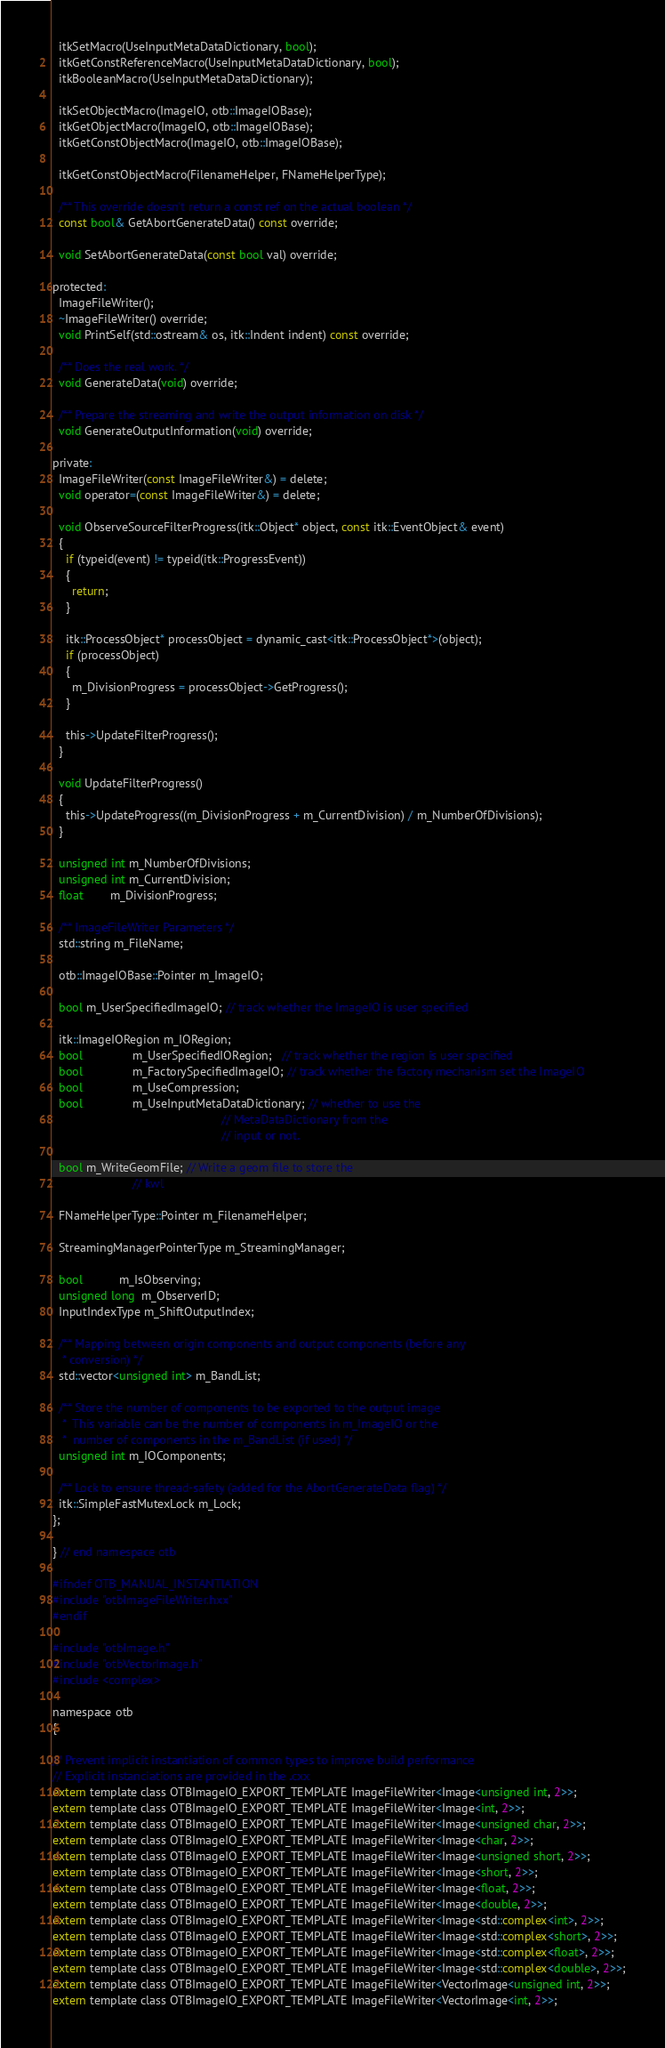<code> <loc_0><loc_0><loc_500><loc_500><_C_>  itkSetMacro(UseInputMetaDataDictionary, bool);
  itkGetConstReferenceMacro(UseInputMetaDataDictionary, bool);
  itkBooleanMacro(UseInputMetaDataDictionary);

  itkSetObjectMacro(ImageIO, otb::ImageIOBase);
  itkGetObjectMacro(ImageIO, otb::ImageIOBase);
  itkGetConstObjectMacro(ImageIO, otb::ImageIOBase);

  itkGetConstObjectMacro(FilenameHelper, FNameHelperType);

  /** This override doesn't return a const ref on the actual boolean */
  const bool& GetAbortGenerateData() const override;

  void SetAbortGenerateData(const bool val) override;

protected:
  ImageFileWriter();
  ~ImageFileWriter() override;
  void PrintSelf(std::ostream& os, itk::Indent indent) const override;

  /** Does the real work. */
  void GenerateData(void) override;

  /** Prepare the streaming and write the output information on disk */
  void GenerateOutputInformation(void) override;

private:
  ImageFileWriter(const ImageFileWriter&) = delete;
  void operator=(const ImageFileWriter&) = delete;

  void ObserveSourceFilterProgress(itk::Object* object, const itk::EventObject& event)
  {
    if (typeid(event) != typeid(itk::ProgressEvent))
    {
      return;
    }

    itk::ProcessObject* processObject = dynamic_cast<itk::ProcessObject*>(object);
    if (processObject)
    {
      m_DivisionProgress = processObject->GetProgress();
    }

    this->UpdateFilterProgress();
  }

  void UpdateFilterProgress()
  {
    this->UpdateProgress((m_DivisionProgress + m_CurrentDivision) / m_NumberOfDivisions);
  }

  unsigned int m_NumberOfDivisions;
  unsigned int m_CurrentDivision;
  float        m_DivisionProgress;

  /** ImageFileWriter Parameters */
  std::string m_FileName;

  otb::ImageIOBase::Pointer m_ImageIO;

  bool m_UserSpecifiedImageIO; // track whether the ImageIO is user specified

  itk::ImageIORegion m_IORegion;
  bool               m_UserSpecifiedIORegion;   // track whether the region is user specified
  bool               m_FactorySpecifiedImageIO; // track whether the factory mechanism set the ImageIO
  bool               m_UseCompression;
  bool               m_UseInputMetaDataDictionary; // whether to use the
                                                   // MetaDataDictionary from the
                                                   // input or not.

  bool m_WriteGeomFile; // Write a geom file to store the
                        // kwl

  FNameHelperType::Pointer m_FilenameHelper;

  StreamingManagerPointerType m_StreamingManager;

  bool           m_IsObserving;
  unsigned long  m_ObserverID;
  InputIndexType m_ShiftOutputIndex;

  /** Mapping between origin components and output components (before any
   * conversion) */
  std::vector<unsigned int> m_BandList;

  /** Store the number of components to be exported to the output image
   *  This variable can be the number of components in m_ImageIO or the
   *  number of components in the m_BandList (if used) */
  unsigned int m_IOComponents;

  /** Lock to ensure thread-safety (added for the AbortGenerateData flag) */
  itk::SimpleFastMutexLock m_Lock;
};

} // end namespace otb

#ifndef OTB_MANUAL_INSTANTIATION
#include "otbImageFileWriter.hxx"
#endif

#include "otbImage.h"
#include "otbVectorImage.h"
#include <complex>

namespace otb
{

// Prevent implicit instantiation of common types to improve build performance
// Explicit instanciations are provided in the .cxx
extern template class OTBImageIO_EXPORT_TEMPLATE ImageFileWriter<Image<unsigned int, 2>>;
extern template class OTBImageIO_EXPORT_TEMPLATE ImageFileWriter<Image<int, 2>>;
extern template class OTBImageIO_EXPORT_TEMPLATE ImageFileWriter<Image<unsigned char, 2>>;
extern template class OTBImageIO_EXPORT_TEMPLATE ImageFileWriter<Image<char, 2>>;
extern template class OTBImageIO_EXPORT_TEMPLATE ImageFileWriter<Image<unsigned short, 2>>;
extern template class OTBImageIO_EXPORT_TEMPLATE ImageFileWriter<Image<short, 2>>;
extern template class OTBImageIO_EXPORT_TEMPLATE ImageFileWriter<Image<float, 2>>;
extern template class OTBImageIO_EXPORT_TEMPLATE ImageFileWriter<Image<double, 2>>;
extern template class OTBImageIO_EXPORT_TEMPLATE ImageFileWriter<Image<std::complex<int>, 2>>;
extern template class OTBImageIO_EXPORT_TEMPLATE ImageFileWriter<Image<std::complex<short>, 2>>;
extern template class OTBImageIO_EXPORT_TEMPLATE ImageFileWriter<Image<std::complex<float>, 2>>;
extern template class OTBImageIO_EXPORT_TEMPLATE ImageFileWriter<Image<std::complex<double>, 2>>;
extern template class OTBImageIO_EXPORT_TEMPLATE ImageFileWriter<VectorImage<unsigned int, 2>>;
extern template class OTBImageIO_EXPORT_TEMPLATE ImageFileWriter<VectorImage<int, 2>>;</code> 